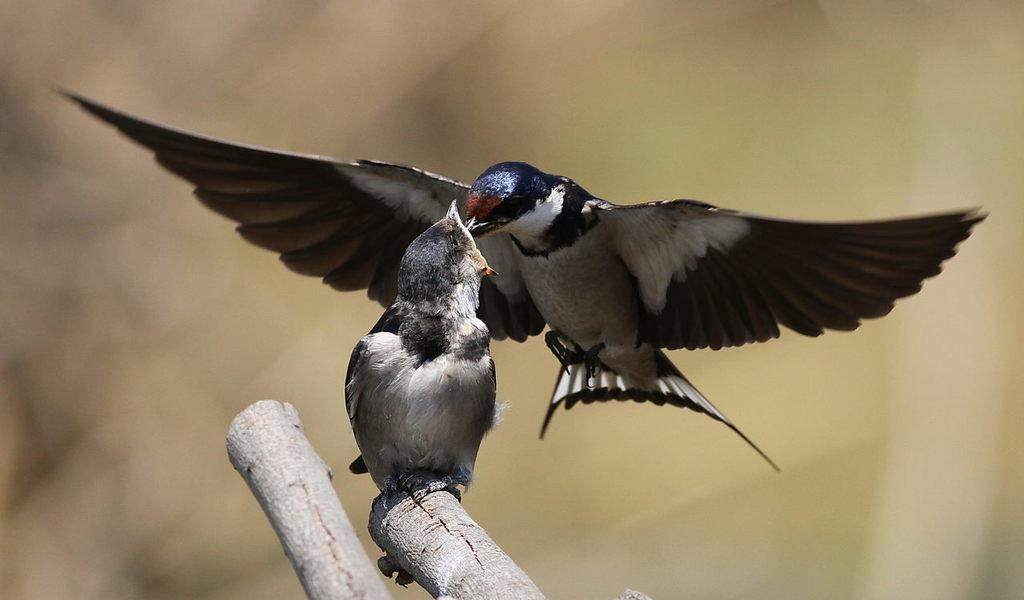What is the main subject of the image? The main subject of the image is two birds in the center. What objects can be seen at the bottom side of the image? There are two wooden bamboos at the bottom side of the image. How would you describe the background of the image? The background area of the image is blurred. What type of cup can be seen in the image? There is no cup present in the image. Can you describe the turkey that is visible in the image? There is no turkey present in the image; it features two birds. 